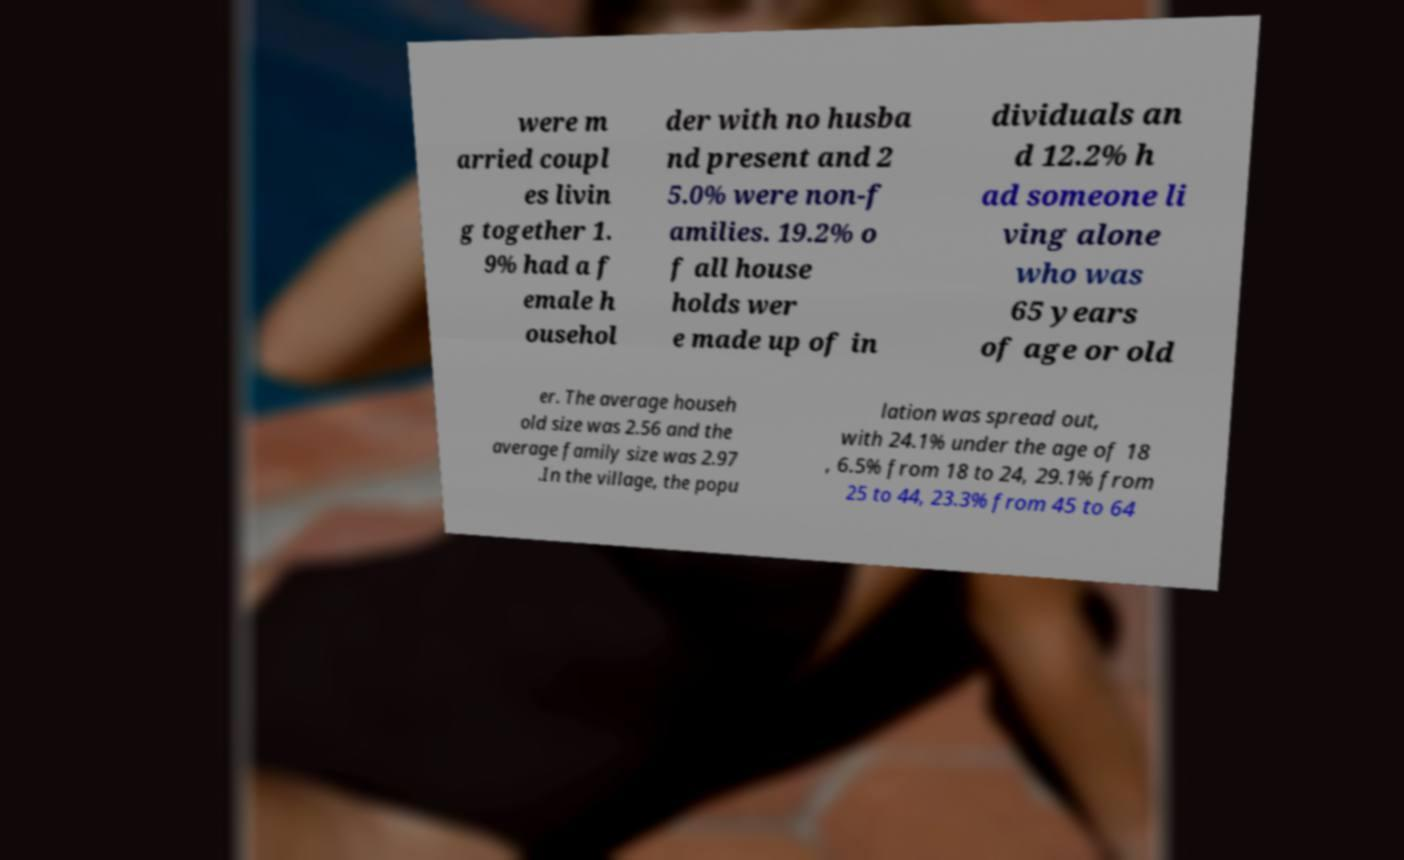What messages or text are displayed in this image? I need them in a readable, typed format. were m arried coupl es livin g together 1. 9% had a f emale h ousehol der with no husba nd present and 2 5.0% were non-f amilies. 19.2% o f all house holds wer e made up of in dividuals an d 12.2% h ad someone li ving alone who was 65 years of age or old er. The average househ old size was 2.56 and the average family size was 2.97 .In the village, the popu lation was spread out, with 24.1% under the age of 18 , 6.5% from 18 to 24, 29.1% from 25 to 44, 23.3% from 45 to 64 